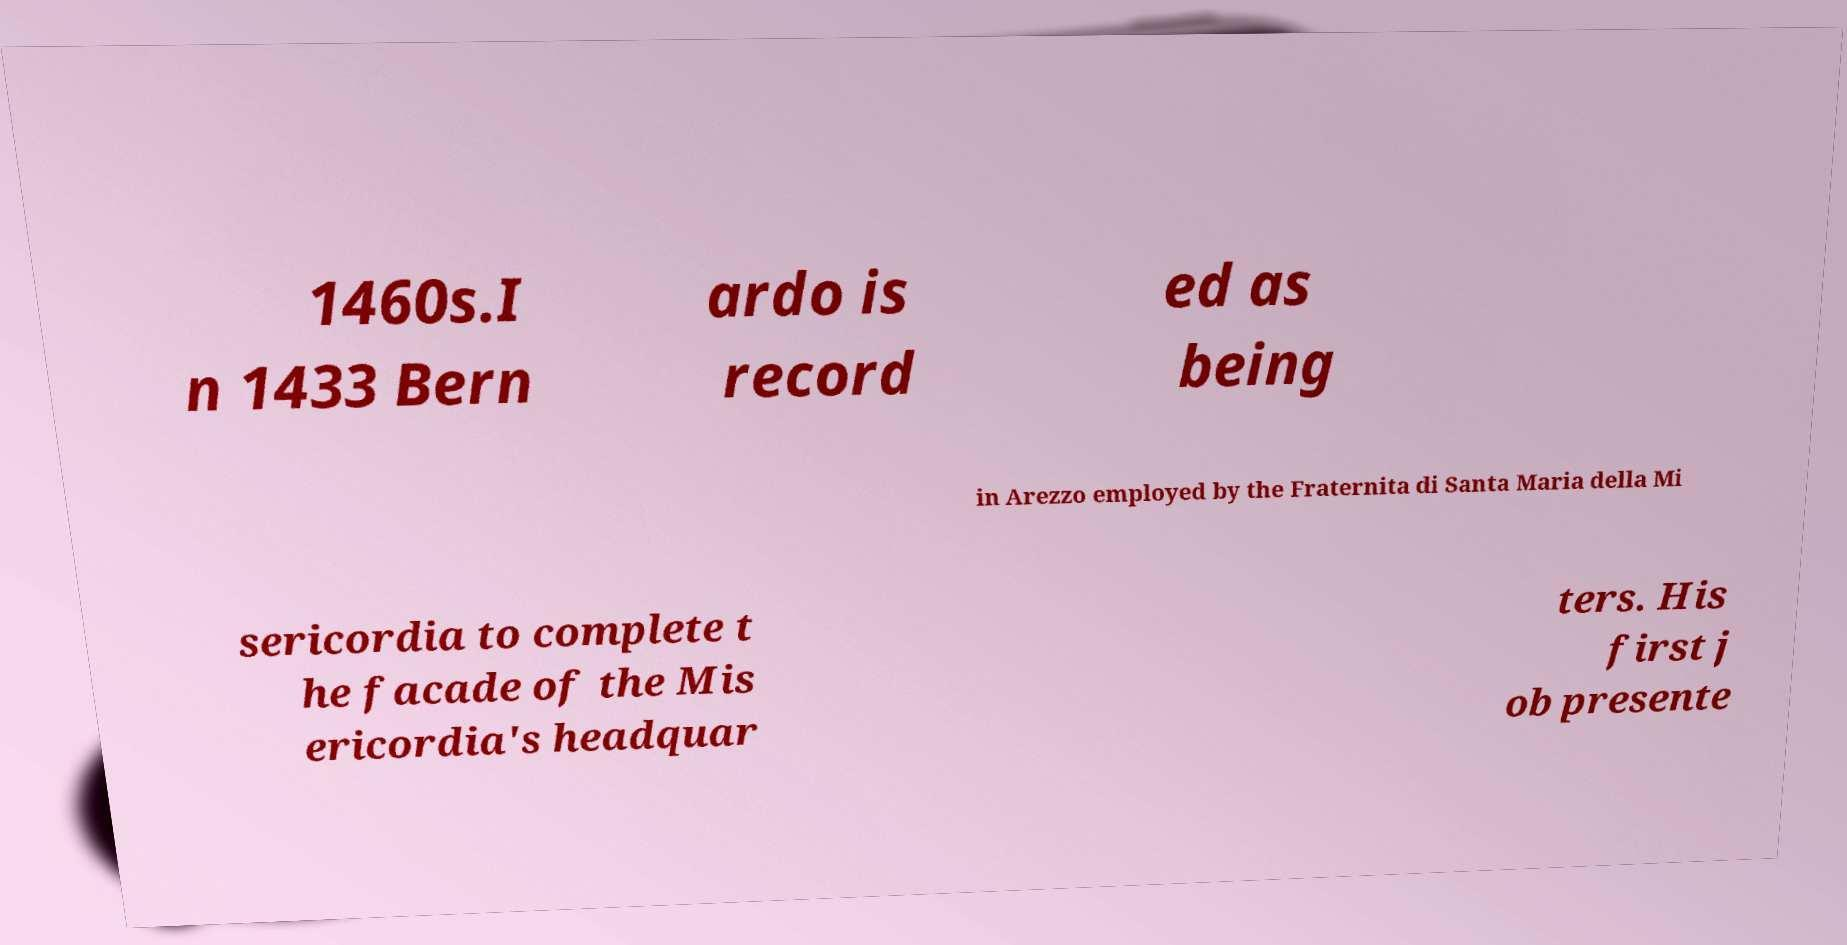What messages or text are displayed in this image? I need them in a readable, typed format. 1460s.I n 1433 Bern ardo is record ed as being in Arezzo employed by the Fraternita di Santa Maria della Mi sericordia to complete t he facade of the Mis ericordia's headquar ters. His first j ob presente 